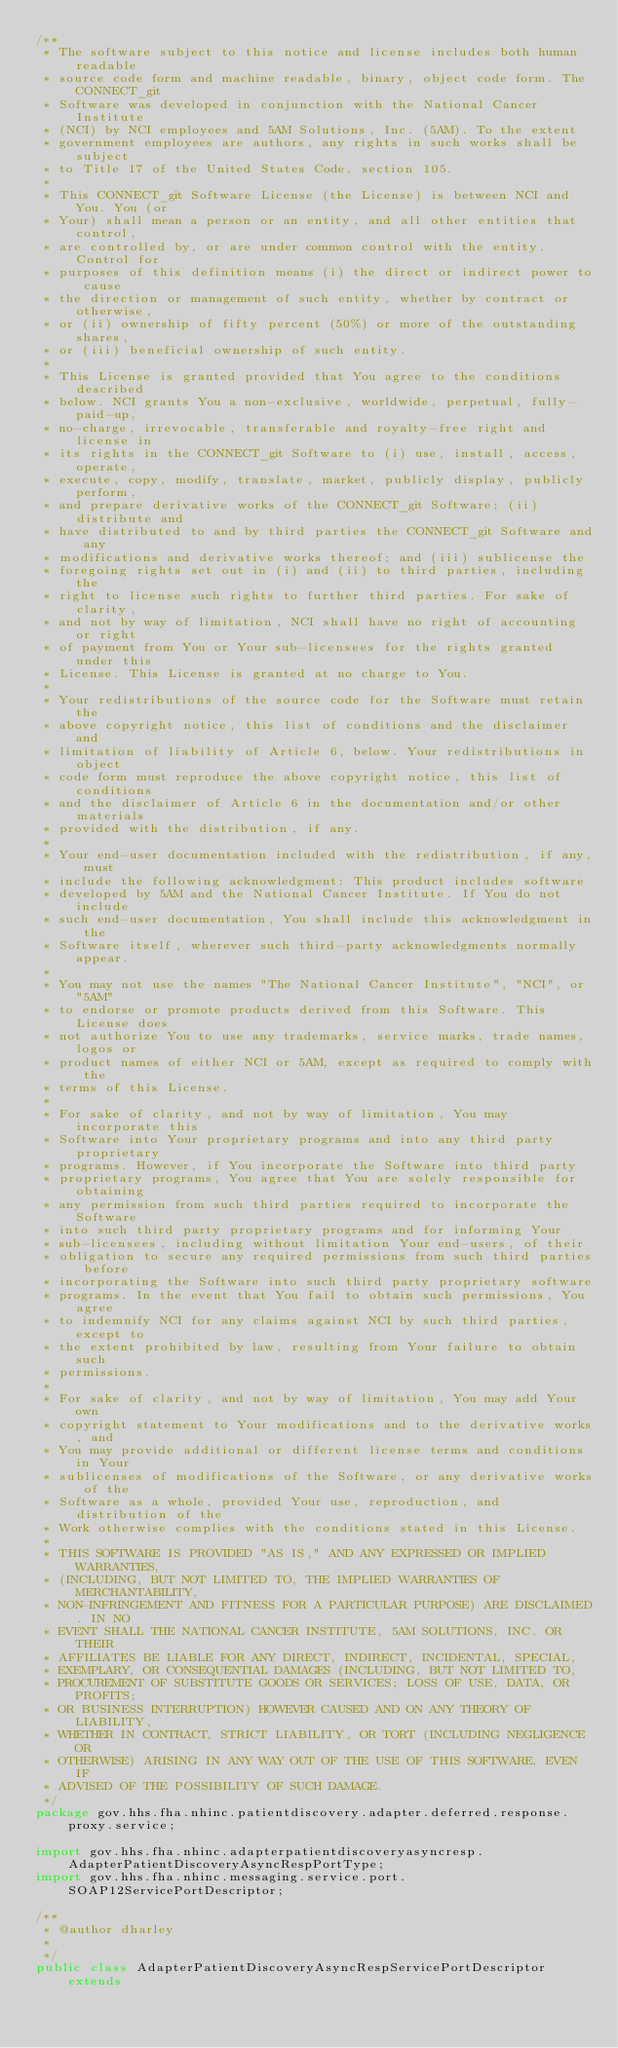<code> <loc_0><loc_0><loc_500><loc_500><_Java_>/**
 * The software subject to this notice and license includes both human readable
 * source code form and machine readable, binary, object code form. The CONNECT_git
 * Software was developed in conjunction with the National Cancer Institute
 * (NCI) by NCI employees and 5AM Solutions, Inc. (5AM). To the extent
 * government employees are authors, any rights in such works shall be subject
 * to Title 17 of the United States Code, section 105.
 *
 * This CONNECT_git Software License (the License) is between NCI and You. You (or
 * Your) shall mean a person or an entity, and all other entities that control,
 * are controlled by, or are under common control with the entity. Control for
 * purposes of this definition means (i) the direct or indirect power to cause
 * the direction or management of such entity, whether by contract or otherwise,
 * or (ii) ownership of fifty percent (50%) or more of the outstanding shares,
 * or (iii) beneficial ownership of such entity.
 *
 * This License is granted provided that You agree to the conditions described
 * below. NCI grants You a non-exclusive, worldwide, perpetual, fully-paid-up,
 * no-charge, irrevocable, transferable and royalty-free right and license in
 * its rights in the CONNECT_git Software to (i) use, install, access, operate,
 * execute, copy, modify, translate, market, publicly display, publicly perform,
 * and prepare derivative works of the CONNECT_git Software; (ii) distribute and
 * have distributed to and by third parties the CONNECT_git Software and any
 * modifications and derivative works thereof; and (iii) sublicense the
 * foregoing rights set out in (i) and (ii) to third parties, including the
 * right to license such rights to further third parties. For sake of clarity,
 * and not by way of limitation, NCI shall have no right of accounting or right
 * of payment from You or Your sub-licensees for the rights granted under this
 * License. This License is granted at no charge to You.
 *
 * Your redistributions of the source code for the Software must retain the
 * above copyright notice, this list of conditions and the disclaimer and
 * limitation of liability of Article 6, below. Your redistributions in object
 * code form must reproduce the above copyright notice, this list of conditions
 * and the disclaimer of Article 6 in the documentation and/or other materials
 * provided with the distribution, if any.
 *
 * Your end-user documentation included with the redistribution, if any, must
 * include the following acknowledgment: This product includes software
 * developed by 5AM and the National Cancer Institute. If You do not include
 * such end-user documentation, You shall include this acknowledgment in the
 * Software itself, wherever such third-party acknowledgments normally appear.
 *
 * You may not use the names "The National Cancer Institute", "NCI", or "5AM"
 * to endorse or promote products derived from this Software. This License does
 * not authorize You to use any trademarks, service marks, trade names, logos or
 * product names of either NCI or 5AM, except as required to comply with the
 * terms of this License.
 *
 * For sake of clarity, and not by way of limitation, You may incorporate this
 * Software into Your proprietary programs and into any third party proprietary
 * programs. However, if You incorporate the Software into third party
 * proprietary programs, You agree that You are solely responsible for obtaining
 * any permission from such third parties required to incorporate the Software
 * into such third party proprietary programs and for informing Your
 * sub-licensees, including without limitation Your end-users, of their
 * obligation to secure any required permissions from such third parties before
 * incorporating the Software into such third party proprietary software
 * programs. In the event that You fail to obtain such permissions, You agree
 * to indemnify NCI for any claims against NCI by such third parties, except to
 * the extent prohibited by law, resulting from Your failure to obtain such
 * permissions.
 *
 * For sake of clarity, and not by way of limitation, You may add Your own
 * copyright statement to Your modifications and to the derivative works, and
 * You may provide additional or different license terms and conditions in Your
 * sublicenses of modifications of the Software, or any derivative works of the
 * Software as a whole, provided Your use, reproduction, and distribution of the
 * Work otherwise complies with the conditions stated in this License.
 *
 * THIS SOFTWARE IS PROVIDED "AS IS," AND ANY EXPRESSED OR IMPLIED WARRANTIES,
 * (INCLUDING, BUT NOT LIMITED TO, THE IMPLIED WARRANTIES OF MERCHANTABILITY,
 * NON-INFRINGEMENT AND FITNESS FOR A PARTICULAR PURPOSE) ARE DISCLAIMED. IN NO
 * EVENT SHALL THE NATIONAL CANCER INSTITUTE, 5AM SOLUTIONS, INC. OR THEIR
 * AFFILIATES BE LIABLE FOR ANY DIRECT, INDIRECT, INCIDENTAL, SPECIAL,
 * EXEMPLARY, OR CONSEQUENTIAL DAMAGES (INCLUDING, BUT NOT LIMITED TO,
 * PROCUREMENT OF SUBSTITUTE GOODS OR SERVICES; LOSS OF USE, DATA, OR PROFITS;
 * OR BUSINESS INTERRUPTION) HOWEVER CAUSED AND ON ANY THEORY OF LIABILITY,
 * WHETHER IN CONTRACT, STRICT LIABILITY, OR TORT (INCLUDING NEGLIGENCE OR
 * OTHERWISE) ARISING IN ANY WAY OUT OF THE USE OF THIS SOFTWARE, EVEN IF
 * ADVISED OF THE POSSIBILITY OF SUCH DAMAGE.
 */
package gov.hhs.fha.nhinc.patientdiscovery.adapter.deferred.response.proxy.service;

import gov.hhs.fha.nhinc.adapterpatientdiscoveryasyncresp.AdapterPatientDiscoveryAsyncRespPortType;
import gov.hhs.fha.nhinc.messaging.service.port.SOAP12ServicePortDescriptor;

/**
 * @author dharley
 * 
 */
public class AdapterPatientDiscoveryAsyncRespServicePortDescriptor extends</code> 